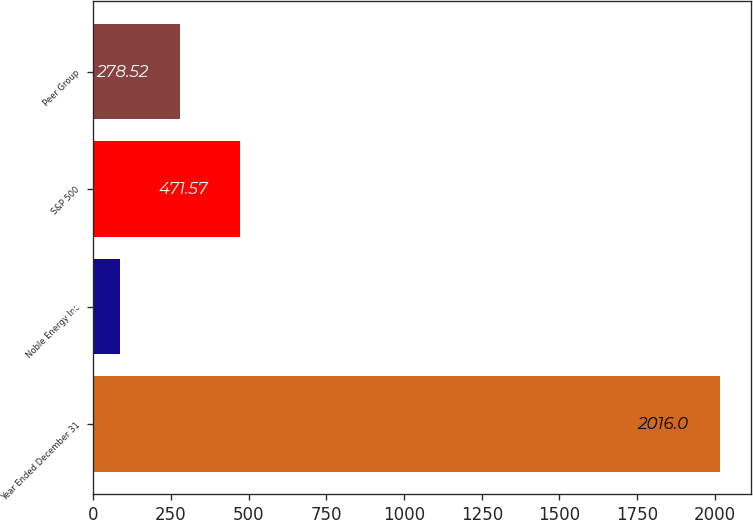Convert chart to OTSL. <chart><loc_0><loc_0><loc_500><loc_500><bar_chart><fcel>Year Ended December 31<fcel>Noble Energy Inc<fcel>S&P 500<fcel>Peer Group<nl><fcel>2016<fcel>85.47<fcel>471.57<fcel>278.52<nl></chart> 